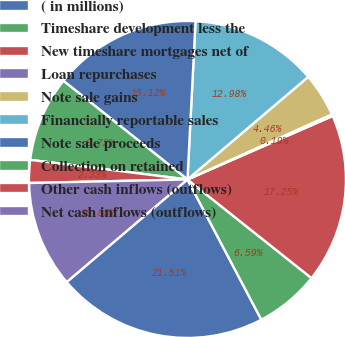Convert chart. <chart><loc_0><loc_0><loc_500><loc_500><pie_chart><fcel>( in millions)<fcel>Timeshare development less the<fcel>New timeshare mortgages net of<fcel>Loan repurchases<fcel>Note sale gains<fcel>Financially reportable sales<fcel>Note sale proceeds<fcel>Collection on retained<fcel>Other cash inflows (outflows)<fcel>Net cash inflows (outflows)<nl><fcel>21.51%<fcel>6.59%<fcel>17.25%<fcel>0.19%<fcel>4.46%<fcel>12.98%<fcel>15.12%<fcel>8.72%<fcel>2.33%<fcel>10.85%<nl></chart> 